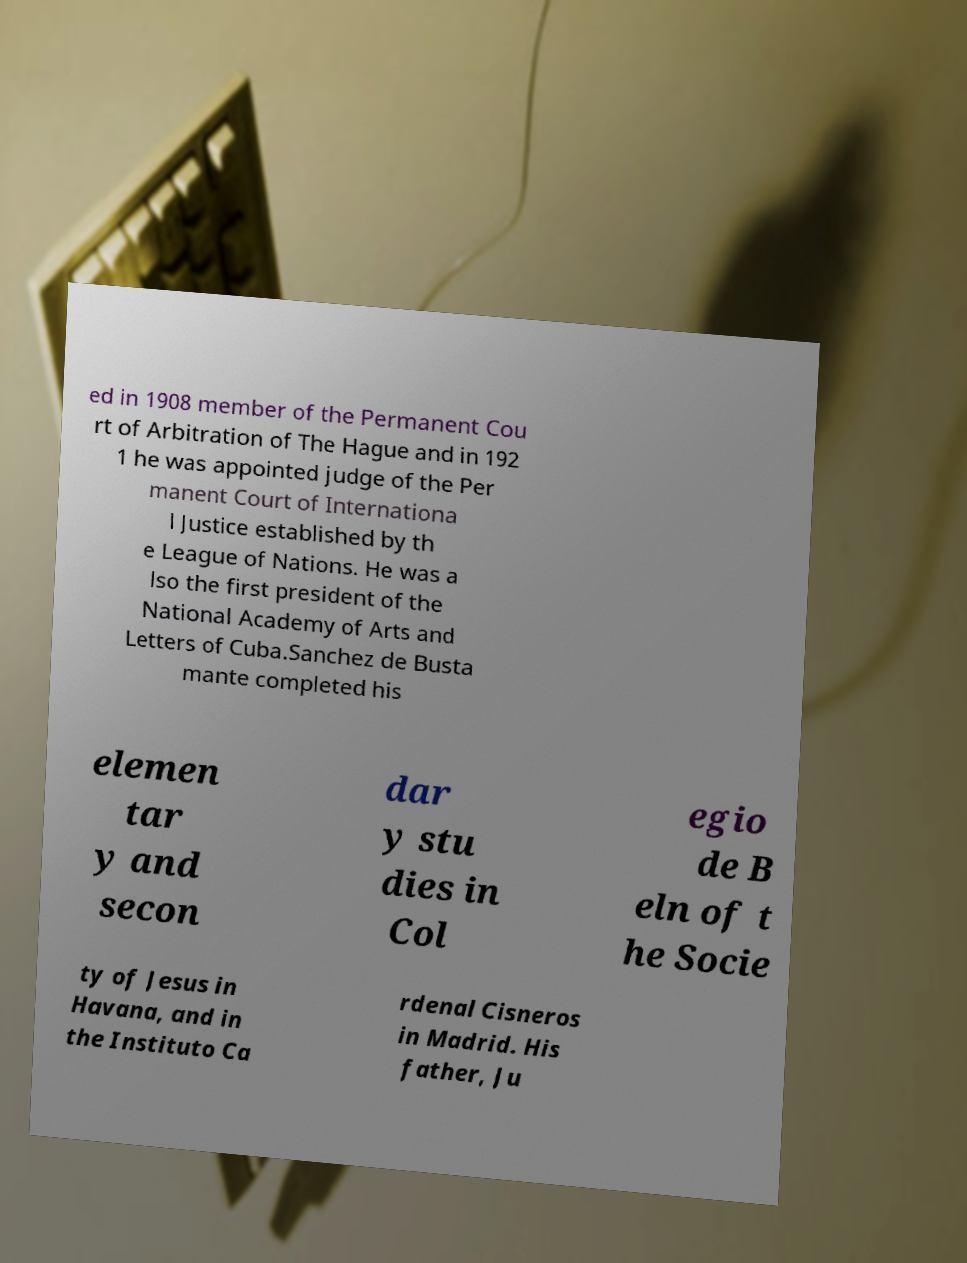I need the written content from this picture converted into text. Can you do that? ed in 1908 member of the Permanent Cou rt of Arbitration of The Hague and in 192 1 he was appointed judge of the Per manent Court of Internationa l Justice established by th e League of Nations. He was a lso the first president of the National Academy of Arts and Letters of Cuba.Sanchez de Busta mante completed his elemen tar y and secon dar y stu dies in Col egio de B eln of t he Socie ty of Jesus in Havana, and in the Instituto Ca rdenal Cisneros in Madrid. His father, Ju 